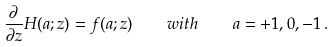Convert formula to latex. <formula><loc_0><loc_0><loc_500><loc_500>\frac { \partial } { \partial z } H ( a ; z ) = f ( a ; z ) \quad w i t h \quad a = + 1 , 0 , - 1 \, .</formula> 